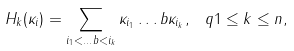Convert formula to latex. <formula><loc_0><loc_0><loc_500><loc_500>H _ { k } ( \kappa _ { i } ) = \sum _ { i _ { 1 } < \dots b < i _ { k } } \kappa _ { i _ { 1 } } \dots b \kappa _ { i _ { k } } , \ q 1 \leq k \leq n ,</formula> 